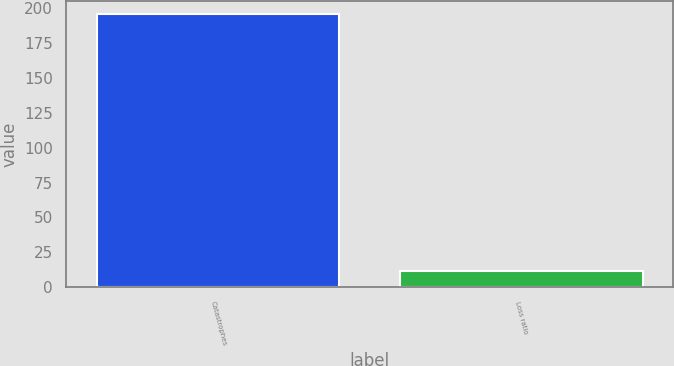Convert chart to OTSL. <chart><loc_0><loc_0><loc_500><loc_500><bar_chart><fcel>Catastrophes<fcel>Loss ratio<nl><fcel>195.5<fcel>11.4<nl></chart> 